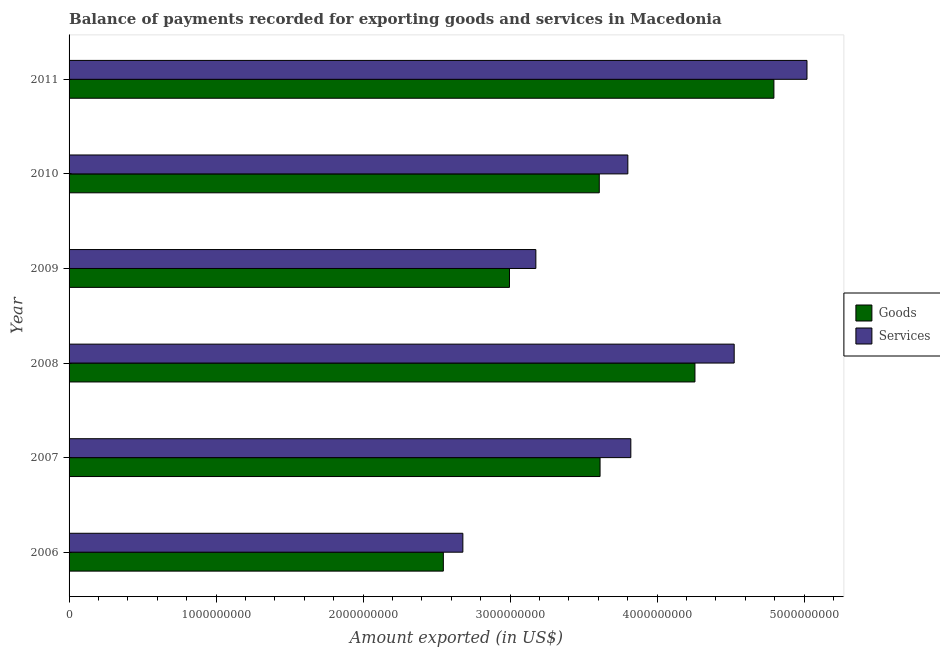How many bars are there on the 6th tick from the top?
Your response must be concise. 2. How many bars are there on the 6th tick from the bottom?
Offer a very short reply. 2. What is the amount of services exported in 2008?
Your answer should be compact. 4.52e+09. Across all years, what is the maximum amount of goods exported?
Your response must be concise. 4.79e+09. Across all years, what is the minimum amount of services exported?
Make the answer very short. 2.68e+09. In which year was the amount of services exported maximum?
Make the answer very short. 2011. In which year was the amount of services exported minimum?
Your answer should be compact. 2006. What is the total amount of services exported in the graph?
Ensure brevity in your answer.  2.30e+1. What is the difference between the amount of goods exported in 2006 and that in 2011?
Your answer should be compact. -2.25e+09. What is the difference between the amount of services exported in 2009 and the amount of goods exported in 2010?
Your response must be concise. -4.31e+08. What is the average amount of services exported per year?
Ensure brevity in your answer.  3.84e+09. In the year 2008, what is the difference between the amount of goods exported and amount of services exported?
Ensure brevity in your answer.  -2.67e+08. What is the ratio of the amount of services exported in 2009 to that in 2010?
Ensure brevity in your answer.  0.83. What is the difference between the highest and the second highest amount of goods exported?
Offer a terse response. 5.37e+08. What is the difference between the highest and the lowest amount of goods exported?
Offer a terse response. 2.25e+09. What does the 1st bar from the top in 2006 represents?
Your answer should be compact. Services. What does the 2nd bar from the bottom in 2006 represents?
Your answer should be very brief. Services. How many bars are there?
Offer a very short reply. 12. What is the difference between two consecutive major ticks on the X-axis?
Provide a short and direct response. 1.00e+09. Are the values on the major ticks of X-axis written in scientific E-notation?
Your answer should be very brief. No. Does the graph contain any zero values?
Offer a very short reply. No. Does the graph contain grids?
Your answer should be very brief. No. What is the title of the graph?
Give a very brief answer. Balance of payments recorded for exporting goods and services in Macedonia. Does "By country of asylum" appear as one of the legend labels in the graph?
Your answer should be very brief. No. What is the label or title of the X-axis?
Provide a succinct answer. Amount exported (in US$). What is the Amount exported (in US$) of Goods in 2006?
Your response must be concise. 2.55e+09. What is the Amount exported (in US$) of Services in 2006?
Your answer should be very brief. 2.68e+09. What is the Amount exported (in US$) of Goods in 2007?
Keep it short and to the point. 3.61e+09. What is the Amount exported (in US$) of Services in 2007?
Offer a very short reply. 3.82e+09. What is the Amount exported (in US$) in Goods in 2008?
Make the answer very short. 4.26e+09. What is the Amount exported (in US$) in Services in 2008?
Make the answer very short. 4.52e+09. What is the Amount exported (in US$) in Goods in 2009?
Your answer should be compact. 3.00e+09. What is the Amount exported (in US$) in Services in 2009?
Keep it short and to the point. 3.18e+09. What is the Amount exported (in US$) in Goods in 2010?
Your response must be concise. 3.61e+09. What is the Amount exported (in US$) of Services in 2010?
Offer a very short reply. 3.80e+09. What is the Amount exported (in US$) of Goods in 2011?
Your answer should be very brief. 4.79e+09. What is the Amount exported (in US$) in Services in 2011?
Provide a short and direct response. 5.02e+09. Across all years, what is the maximum Amount exported (in US$) of Goods?
Your response must be concise. 4.79e+09. Across all years, what is the maximum Amount exported (in US$) in Services?
Ensure brevity in your answer.  5.02e+09. Across all years, what is the minimum Amount exported (in US$) of Goods?
Your answer should be very brief. 2.55e+09. Across all years, what is the minimum Amount exported (in US$) in Services?
Provide a short and direct response. 2.68e+09. What is the total Amount exported (in US$) of Goods in the graph?
Provide a short and direct response. 2.18e+1. What is the total Amount exported (in US$) in Services in the graph?
Your answer should be very brief. 2.30e+1. What is the difference between the Amount exported (in US$) of Goods in 2006 and that in 2007?
Your answer should be very brief. -1.07e+09. What is the difference between the Amount exported (in US$) in Services in 2006 and that in 2007?
Your answer should be very brief. -1.14e+09. What is the difference between the Amount exported (in US$) in Goods in 2006 and that in 2008?
Ensure brevity in your answer.  -1.71e+09. What is the difference between the Amount exported (in US$) of Services in 2006 and that in 2008?
Your answer should be compact. -1.85e+09. What is the difference between the Amount exported (in US$) in Goods in 2006 and that in 2009?
Ensure brevity in your answer.  -4.50e+08. What is the difference between the Amount exported (in US$) in Services in 2006 and that in 2009?
Your response must be concise. -4.97e+08. What is the difference between the Amount exported (in US$) in Goods in 2006 and that in 2010?
Offer a terse response. -1.06e+09. What is the difference between the Amount exported (in US$) in Services in 2006 and that in 2010?
Your response must be concise. -1.12e+09. What is the difference between the Amount exported (in US$) of Goods in 2006 and that in 2011?
Provide a succinct answer. -2.25e+09. What is the difference between the Amount exported (in US$) in Services in 2006 and that in 2011?
Your response must be concise. -2.34e+09. What is the difference between the Amount exported (in US$) in Goods in 2007 and that in 2008?
Your response must be concise. -6.45e+08. What is the difference between the Amount exported (in US$) in Services in 2007 and that in 2008?
Make the answer very short. -7.03e+08. What is the difference between the Amount exported (in US$) of Goods in 2007 and that in 2009?
Your answer should be very brief. 6.16e+08. What is the difference between the Amount exported (in US$) of Services in 2007 and that in 2009?
Provide a succinct answer. 6.46e+08. What is the difference between the Amount exported (in US$) of Goods in 2007 and that in 2010?
Provide a short and direct response. 5.36e+06. What is the difference between the Amount exported (in US$) of Services in 2007 and that in 2010?
Offer a very short reply. 2.02e+07. What is the difference between the Amount exported (in US$) of Goods in 2007 and that in 2011?
Make the answer very short. -1.18e+09. What is the difference between the Amount exported (in US$) of Services in 2007 and that in 2011?
Provide a short and direct response. -1.20e+09. What is the difference between the Amount exported (in US$) of Goods in 2008 and that in 2009?
Your response must be concise. 1.26e+09. What is the difference between the Amount exported (in US$) in Services in 2008 and that in 2009?
Ensure brevity in your answer.  1.35e+09. What is the difference between the Amount exported (in US$) in Goods in 2008 and that in 2010?
Offer a terse response. 6.51e+08. What is the difference between the Amount exported (in US$) in Services in 2008 and that in 2010?
Your answer should be very brief. 7.23e+08. What is the difference between the Amount exported (in US$) of Goods in 2008 and that in 2011?
Give a very brief answer. -5.37e+08. What is the difference between the Amount exported (in US$) in Services in 2008 and that in 2011?
Ensure brevity in your answer.  -4.95e+08. What is the difference between the Amount exported (in US$) in Goods in 2009 and that in 2010?
Ensure brevity in your answer.  -6.11e+08. What is the difference between the Amount exported (in US$) of Services in 2009 and that in 2010?
Your response must be concise. -6.26e+08. What is the difference between the Amount exported (in US$) in Goods in 2009 and that in 2011?
Give a very brief answer. -1.80e+09. What is the difference between the Amount exported (in US$) of Services in 2009 and that in 2011?
Your answer should be compact. -1.84e+09. What is the difference between the Amount exported (in US$) in Goods in 2010 and that in 2011?
Keep it short and to the point. -1.19e+09. What is the difference between the Amount exported (in US$) in Services in 2010 and that in 2011?
Give a very brief answer. -1.22e+09. What is the difference between the Amount exported (in US$) in Goods in 2006 and the Amount exported (in US$) in Services in 2007?
Your response must be concise. -1.28e+09. What is the difference between the Amount exported (in US$) of Goods in 2006 and the Amount exported (in US$) of Services in 2008?
Keep it short and to the point. -1.98e+09. What is the difference between the Amount exported (in US$) of Goods in 2006 and the Amount exported (in US$) of Services in 2009?
Make the answer very short. -6.29e+08. What is the difference between the Amount exported (in US$) in Goods in 2006 and the Amount exported (in US$) in Services in 2010?
Provide a succinct answer. -1.25e+09. What is the difference between the Amount exported (in US$) in Goods in 2006 and the Amount exported (in US$) in Services in 2011?
Your response must be concise. -2.47e+09. What is the difference between the Amount exported (in US$) in Goods in 2007 and the Amount exported (in US$) in Services in 2008?
Make the answer very short. -9.12e+08. What is the difference between the Amount exported (in US$) in Goods in 2007 and the Amount exported (in US$) in Services in 2009?
Your answer should be compact. 4.37e+08. What is the difference between the Amount exported (in US$) of Goods in 2007 and the Amount exported (in US$) of Services in 2010?
Ensure brevity in your answer.  -1.89e+08. What is the difference between the Amount exported (in US$) in Goods in 2007 and the Amount exported (in US$) in Services in 2011?
Provide a short and direct response. -1.41e+09. What is the difference between the Amount exported (in US$) in Goods in 2008 and the Amount exported (in US$) in Services in 2009?
Offer a terse response. 1.08e+09. What is the difference between the Amount exported (in US$) of Goods in 2008 and the Amount exported (in US$) of Services in 2010?
Provide a succinct answer. 4.56e+08. What is the difference between the Amount exported (in US$) of Goods in 2008 and the Amount exported (in US$) of Services in 2011?
Give a very brief answer. -7.62e+08. What is the difference between the Amount exported (in US$) of Goods in 2009 and the Amount exported (in US$) of Services in 2010?
Give a very brief answer. -8.05e+08. What is the difference between the Amount exported (in US$) of Goods in 2009 and the Amount exported (in US$) of Services in 2011?
Offer a terse response. -2.02e+09. What is the difference between the Amount exported (in US$) in Goods in 2010 and the Amount exported (in US$) in Services in 2011?
Ensure brevity in your answer.  -1.41e+09. What is the average Amount exported (in US$) in Goods per year?
Offer a very short reply. 3.64e+09. What is the average Amount exported (in US$) in Services per year?
Your answer should be very brief. 3.84e+09. In the year 2006, what is the difference between the Amount exported (in US$) of Goods and Amount exported (in US$) of Services?
Your response must be concise. -1.33e+08. In the year 2007, what is the difference between the Amount exported (in US$) in Goods and Amount exported (in US$) in Services?
Keep it short and to the point. -2.09e+08. In the year 2008, what is the difference between the Amount exported (in US$) in Goods and Amount exported (in US$) in Services?
Your response must be concise. -2.67e+08. In the year 2009, what is the difference between the Amount exported (in US$) in Goods and Amount exported (in US$) in Services?
Make the answer very short. -1.79e+08. In the year 2010, what is the difference between the Amount exported (in US$) in Goods and Amount exported (in US$) in Services?
Keep it short and to the point. -1.94e+08. In the year 2011, what is the difference between the Amount exported (in US$) of Goods and Amount exported (in US$) of Services?
Keep it short and to the point. -2.25e+08. What is the ratio of the Amount exported (in US$) in Goods in 2006 to that in 2007?
Offer a terse response. 0.7. What is the ratio of the Amount exported (in US$) in Services in 2006 to that in 2007?
Offer a terse response. 0.7. What is the ratio of the Amount exported (in US$) of Goods in 2006 to that in 2008?
Provide a succinct answer. 0.6. What is the ratio of the Amount exported (in US$) of Services in 2006 to that in 2008?
Give a very brief answer. 0.59. What is the ratio of the Amount exported (in US$) in Goods in 2006 to that in 2009?
Offer a very short reply. 0.85. What is the ratio of the Amount exported (in US$) in Services in 2006 to that in 2009?
Offer a terse response. 0.84. What is the ratio of the Amount exported (in US$) in Goods in 2006 to that in 2010?
Make the answer very short. 0.71. What is the ratio of the Amount exported (in US$) in Services in 2006 to that in 2010?
Provide a succinct answer. 0.7. What is the ratio of the Amount exported (in US$) of Goods in 2006 to that in 2011?
Ensure brevity in your answer.  0.53. What is the ratio of the Amount exported (in US$) in Services in 2006 to that in 2011?
Your answer should be very brief. 0.53. What is the ratio of the Amount exported (in US$) in Goods in 2007 to that in 2008?
Your answer should be compact. 0.85. What is the ratio of the Amount exported (in US$) of Services in 2007 to that in 2008?
Give a very brief answer. 0.84. What is the ratio of the Amount exported (in US$) of Goods in 2007 to that in 2009?
Your response must be concise. 1.21. What is the ratio of the Amount exported (in US$) in Services in 2007 to that in 2009?
Provide a succinct answer. 1.2. What is the ratio of the Amount exported (in US$) of Services in 2007 to that in 2010?
Your answer should be very brief. 1.01. What is the ratio of the Amount exported (in US$) of Goods in 2007 to that in 2011?
Offer a very short reply. 0.75. What is the ratio of the Amount exported (in US$) of Services in 2007 to that in 2011?
Offer a terse response. 0.76. What is the ratio of the Amount exported (in US$) of Goods in 2008 to that in 2009?
Provide a short and direct response. 1.42. What is the ratio of the Amount exported (in US$) of Services in 2008 to that in 2009?
Your response must be concise. 1.42. What is the ratio of the Amount exported (in US$) in Goods in 2008 to that in 2010?
Ensure brevity in your answer.  1.18. What is the ratio of the Amount exported (in US$) in Services in 2008 to that in 2010?
Your answer should be very brief. 1.19. What is the ratio of the Amount exported (in US$) in Goods in 2008 to that in 2011?
Your answer should be compact. 0.89. What is the ratio of the Amount exported (in US$) in Services in 2008 to that in 2011?
Provide a succinct answer. 0.9. What is the ratio of the Amount exported (in US$) of Goods in 2009 to that in 2010?
Your response must be concise. 0.83. What is the ratio of the Amount exported (in US$) in Services in 2009 to that in 2010?
Provide a succinct answer. 0.84. What is the ratio of the Amount exported (in US$) of Goods in 2009 to that in 2011?
Offer a terse response. 0.62. What is the ratio of the Amount exported (in US$) of Services in 2009 to that in 2011?
Provide a succinct answer. 0.63. What is the ratio of the Amount exported (in US$) in Goods in 2010 to that in 2011?
Provide a succinct answer. 0.75. What is the ratio of the Amount exported (in US$) of Services in 2010 to that in 2011?
Give a very brief answer. 0.76. What is the difference between the highest and the second highest Amount exported (in US$) of Goods?
Make the answer very short. 5.37e+08. What is the difference between the highest and the second highest Amount exported (in US$) of Services?
Give a very brief answer. 4.95e+08. What is the difference between the highest and the lowest Amount exported (in US$) in Goods?
Your response must be concise. 2.25e+09. What is the difference between the highest and the lowest Amount exported (in US$) in Services?
Offer a terse response. 2.34e+09. 